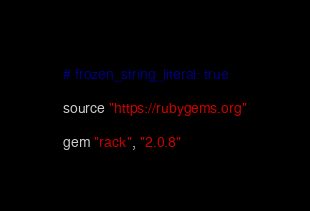<code> <loc_0><loc_0><loc_500><loc_500><_Ruby_># frozen_string_literal: true

source "https://rubygems.org"

gem "rack", "2.0.8"</code> 